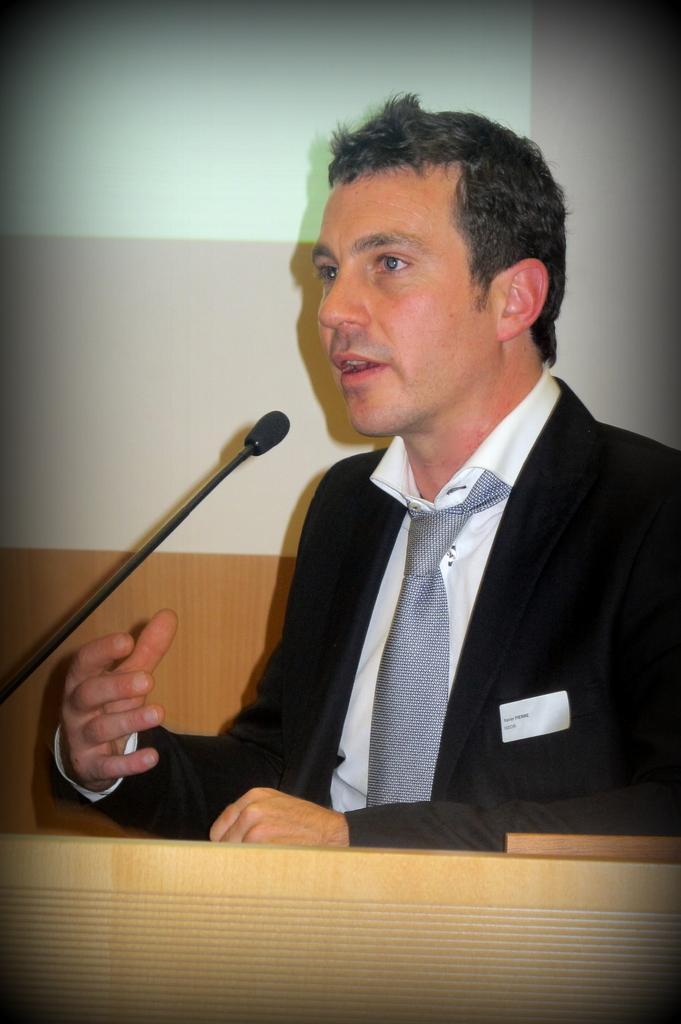In one or two sentences, can you explain what this image depicts? In this image I can see a man, I can see he is wearing black blazer, white shirt and a tie. Here I can see white colour thing and I can also see a mic over here. 